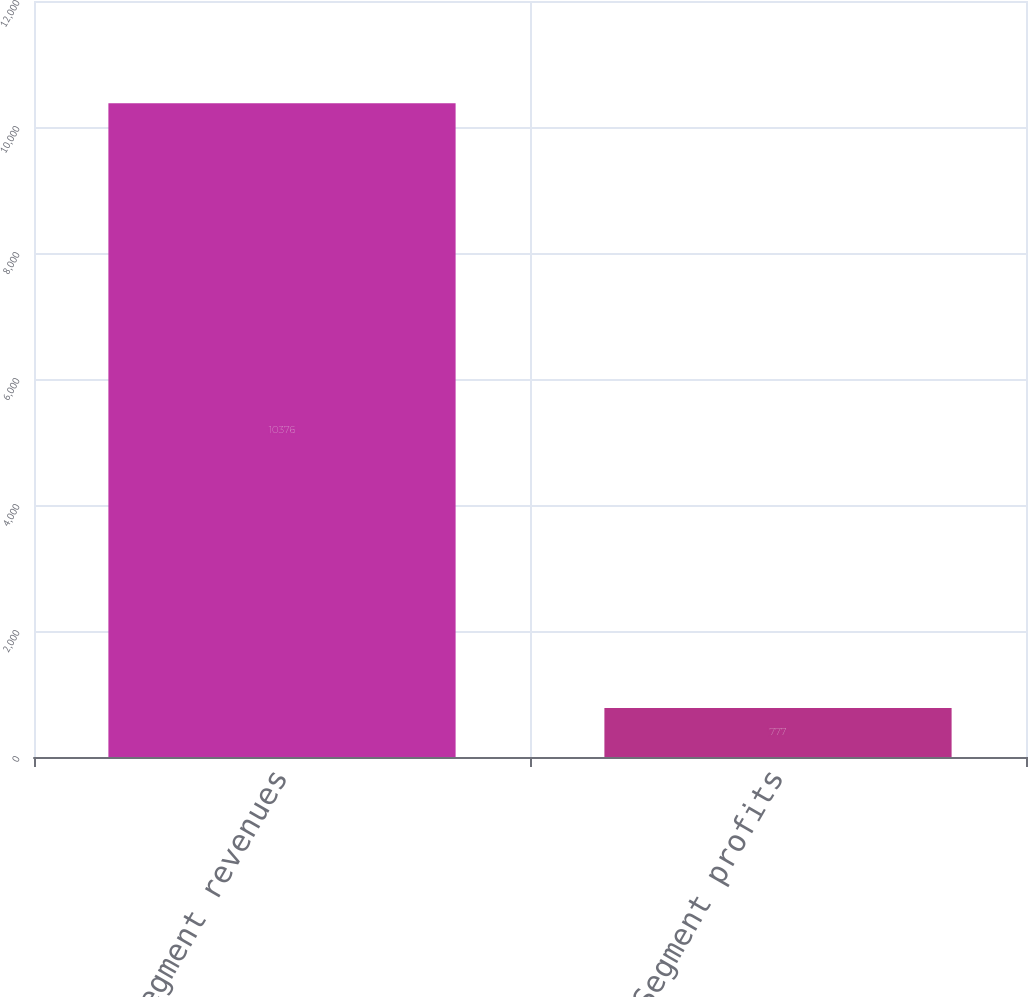Convert chart. <chart><loc_0><loc_0><loc_500><loc_500><bar_chart><fcel>Segment revenues<fcel>Segment profits<nl><fcel>10376<fcel>777<nl></chart> 